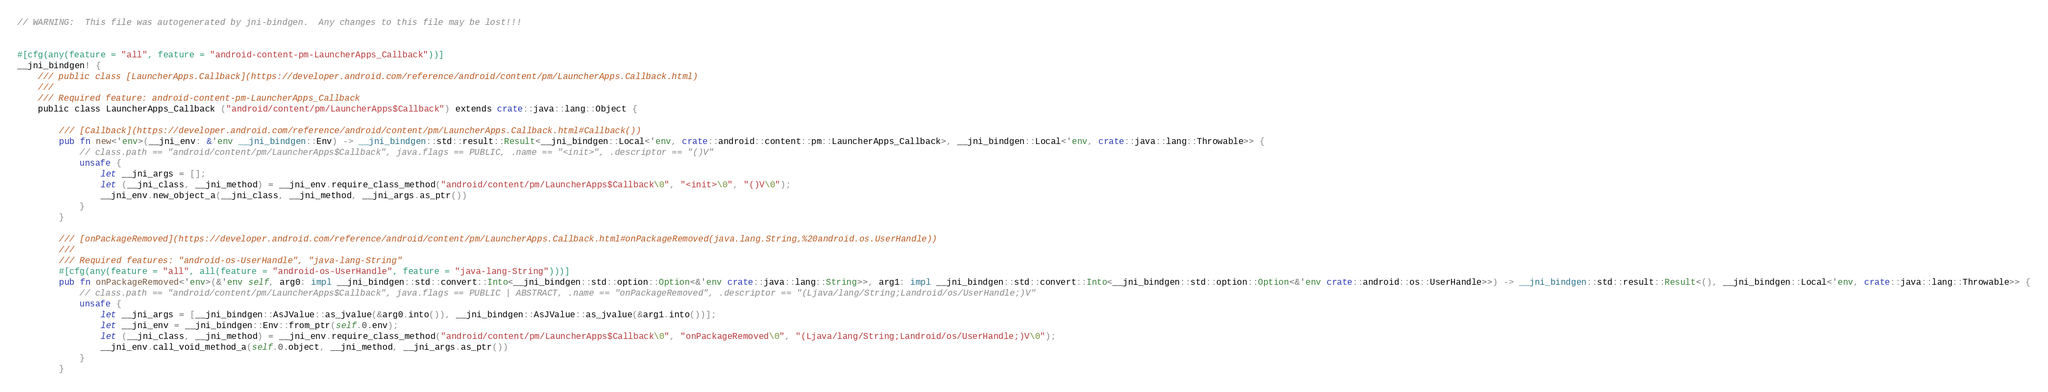Convert code to text. <code><loc_0><loc_0><loc_500><loc_500><_Rust_>// WARNING:  This file was autogenerated by jni-bindgen.  Any changes to this file may be lost!!!


#[cfg(any(feature = "all", feature = "android-content-pm-LauncherApps_Callback"))]
__jni_bindgen! {
    /// public class [LauncherApps.Callback](https://developer.android.com/reference/android/content/pm/LauncherApps.Callback.html)
    ///
    /// Required feature: android-content-pm-LauncherApps_Callback
    public class LauncherApps_Callback ("android/content/pm/LauncherApps$Callback") extends crate::java::lang::Object {

        /// [Callback](https://developer.android.com/reference/android/content/pm/LauncherApps.Callback.html#Callback())
        pub fn new<'env>(__jni_env: &'env __jni_bindgen::Env) -> __jni_bindgen::std::result::Result<__jni_bindgen::Local<'env, crate::android::content::pm::LauncherApps_Callback>, __jni_bindgen::Local<'env, crate::java::lang::Throwable>> {
            // class.path == "android/content/pm/LauncherApps$Callback", java.flags == PUBLIC, .name == "<init>", .descriptor == "()V"
            unsafe {
                let __jni_args = [];
                let (__jni_class, __jni_method) = __jni_env.require_class_method("android/content/pm/LauncherApps$Callback\0", "<init>\0", "()V\0");
                __jni_env.new_object_a(__jni_class, __jni_method, __jni_args.as_ptr())
            }
        }

        /// [onPackageRemoved](https://developer.android.com/reference/android/content/pm/LauncherApps.Callback.html#onPackageRemoved(java.lang.String,%20android.os.UserHandle))
        ///
        /// Required features: "android-os-UserHandle", "java-lang-String"
        #[cfg(any(feature = "all", all(feature = "android-os-UserHandle", feature = "java-lang-String")))]
        pub fn onPackageRemoved<'env>(&'env self, arg0: impl __jni_bindgen::std::convert::Into<__jni_bindgen::std::option::Option<&'env crate::java::lang::String>>, arg1: impl __jni_bindgen::std::convert::Into<__jni_bindgen::std::option::Option<&'env crate::android::os::UserHandle>>) -> __jni_bindgen::std::result::Result<(), __jni_bindgen::Local<'env, crate::java::lang::Throwable>> {
            // class.path == "android/content/pm/LauncherApps$Callback", java.flags == PUBLIC | ABSTRACT, .name == "onPackageRemoved", .descriptor == "(Ljava/lang/String;Landroid/os/UserHandle;)V"
            unsafe {
                let __jni_args = [__jni_bindgen::AsJValue::as_jvalue(&arg0.into()), __jni_bindgen::AsJValue::as_jvalue(&arg1.into())];
                let __jni_env = __jni_bindgen::Env::from_ptr(self.0.env);
                let (__jni_class, __jni_method) = __jni_env.require_class_method("android/content/pm/LauncherApps$Callback\0", "onPackageRemoved\0", "(Ljava/lang/String;Landroid/os/UserHandle;)V\0");
                __jni_env.call_void_method_a(self.0.object, __jni_method, __jni_args.as_ptr())
            }
        }
</code> 